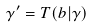Convert formula to latex. <formula><loc_0><loc_0><loc_500><loc_500>\gamma ^ { \prime } = T ( b | \gamma )</formula> 